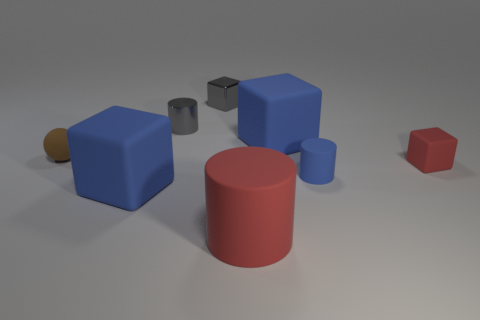Is there anything else that is the same color as the metallic cylinder?
Keep it short and to the point. Yes. There is a blue object that is behind the brown rubber object; is it the same size as the big red cylinder?
Provide a short and direct response. Yes. How many blue rubber cylinders are behind the large rubber cube that is behind the small brown sphere?
Offer a very short reply. 0. There is a big rubber object that is behind the blue rubber cube that is in front of the brown object; is there a tiny rubber object on the left side of it?
Offer a terse response. Yes. There is a small gray thing that is the same shape as the big red rubber thing; what is it made of?
Keep it short and to the point. Metal. Are the gray cylinder and the tiny cube behind the brown object made of the same material?
Your answer should be compact. Yes. There is a small rubber object on the left side of the large matte cube that is right of the large cylinder; what shape is it?
Your answer should be compact. Sphere. How many tiny objects are red rubber cylinders or blue matte things?
Provide a succinct answer. 1. How many small gray things have the same shape as the small blue object?
Make the answer very short. 1. There is a brown matte thing; is its shape the same as the large matte object on the right side of the big red cylinder?
Your response must be concise. No. 